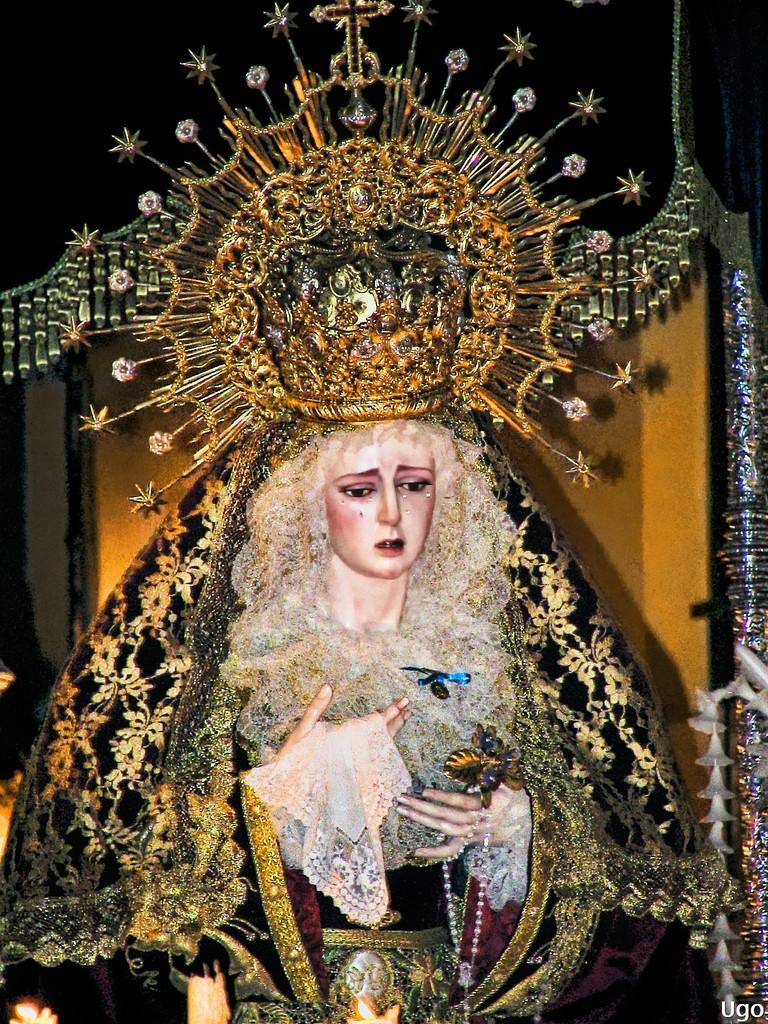What is depicted in the image? There is a painting of a woman in the image. What is the woman in the painting wearing on her head? The woman in the painting is wearing a crown. What else is the woman in the painting wearing? The woman in the painting is wearing clothes. Is there any additional information about the image itself? Yes, there is a watermark in the bottom right corner of the image. How many dolls are sitting in the basket next to the painting? There is no basket or dolls present in the image; it only features a painting of a woman. 